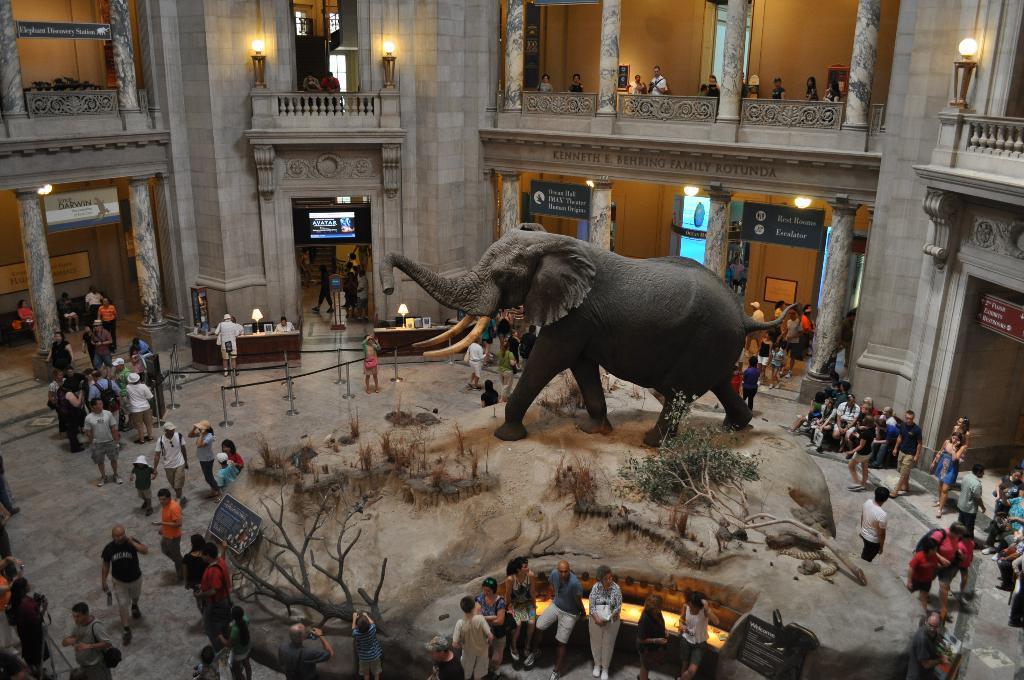Describe this image in one or two sentences. In the picture we can see inside the mall and in the middle of the floor, we can see a structure of the elephant and near it, we can see some dried trees and plants and near it, we can see a sofa and some people are sitting in it and around it we can see some people are walking and some people are standing and in the background we can see some pillars and lights to the walls. 